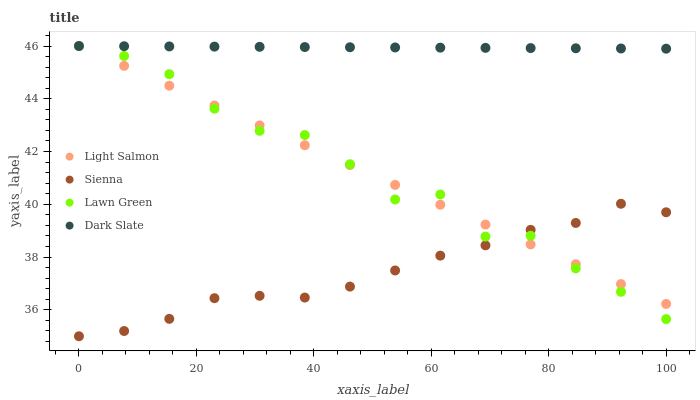Does Sienna have the minimum area under the curve?
Answer yes or no. Yes. Does Dark Slate have the maximum area under the curve?
Answer yes or no. Yes. Does Lawn Green have the minimum area under the curve?
Answer yes or no. No. Does Lawn Green have the maximum area under the curve?
Answer yes or no. No. Is Light Salmon the smoothest?
Answer yes or no. Yes. Is Lawn Green the roughest?
Answer yes or no. Yes. Is Lawn Green the smoothest?
Answer yes or no. No. Is Light Salmon the roughest?
Answer yes or no. No. Does Sienna have the lowest value?
Answer yes or no. Yes. Does Lawn Green have the lowest value?
Answer yes or no. No. Does Dark Slate have the highest value?
Answer yes or no. Yes. Is Sienna less than Dark Slate?
Answer yes or no. Yes. Is Dark Slate greater than Sienna?
Answer yes or no. Yes. Does Light Salmon intersect Sienna?
Answer yes or no. Yes. Is Light Salmon less than Sienna?
Answer yes or no. No. Is Light Salmon greater than Sienna?
Answer yes or no. No. Does Sienna intersect Dark Slate?
Answer yes or no. No. 